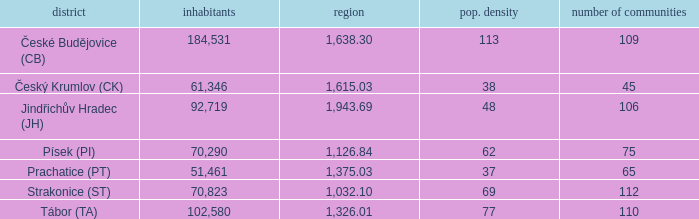What is the population with an area of 1,126.84? 70290.0. 